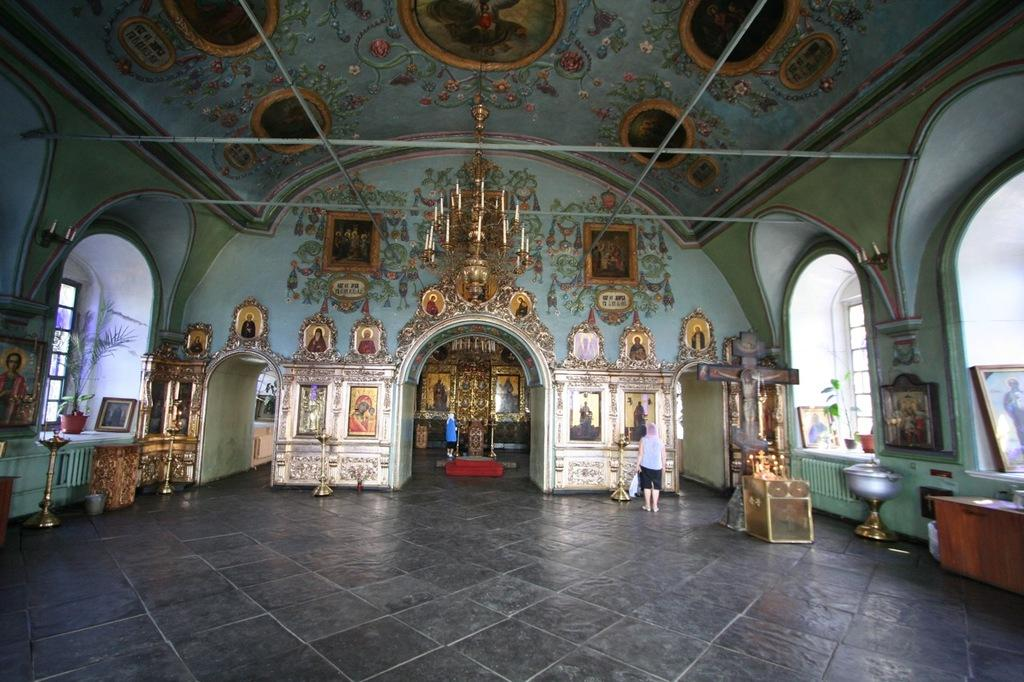What type of space is shown in the image? The image is an interior view of a room. What lighting fixture is present in the room? There is a chandelier in the room. What is the structure that covers the room? The room has a roof. What are the long, thin bars used for in the room? There are rods in the room, which may be used for hanging curtains or other purposes. What is the frame likely used for in the room? There is a frame in the room, which may be used for displaying artwork or photographs. What is the surface that people walk on in the room? The room has a floor. Who is present in the room? A person is standing in the room. What can be found in the room besides the chandelier and the person? There are objects present in the room, but their specific nature is not mentioned. What piece of furniture is present in the room? There is a table in the room. What type of glove is being used to apply paste on the board in the image? There is no glove, paste, or board present in the image. 